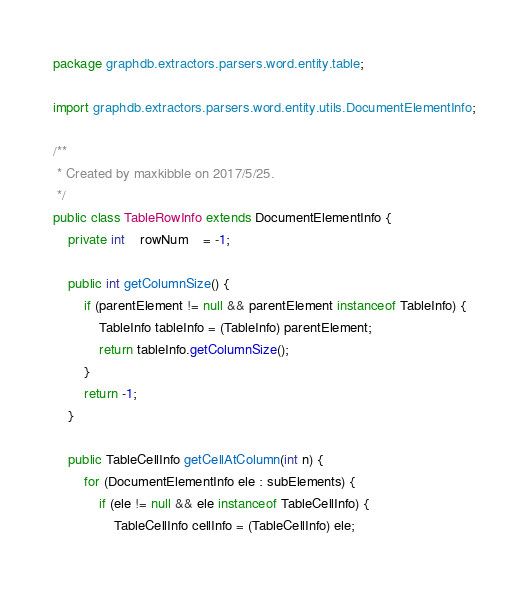<code> <loc_0><loc_0><loc_500><loc_500><_Java_>package graphdb.extractors.parsers.word.entity.table;

import graphdb.extractors.parsers.word.entity.utils.DocumentElementInfo;

/**
 * Created by maxkibble on 2017/5/25.
 */
public class TableRowInfo extends DocumentElementInfo {
    private int	rowNum	= -1;

    public int getColumnSize() {
        if (parentElement != null && parentElement instanceof TableInfo) {
            TableInfo tableInfo = (TableInfo) parentElement;
            return tableInfo.getColumnSize();
        }
        return -1;
    }

    public TableCellInfo getCellAtColumn(int n) {
        for (DocumentElementInfo ele : subElements) {
            if (ele != null && ele instanceof TableCellInfo) {
                TableCellInfo cellInfo = (TableCellInfo) ele;</code> 